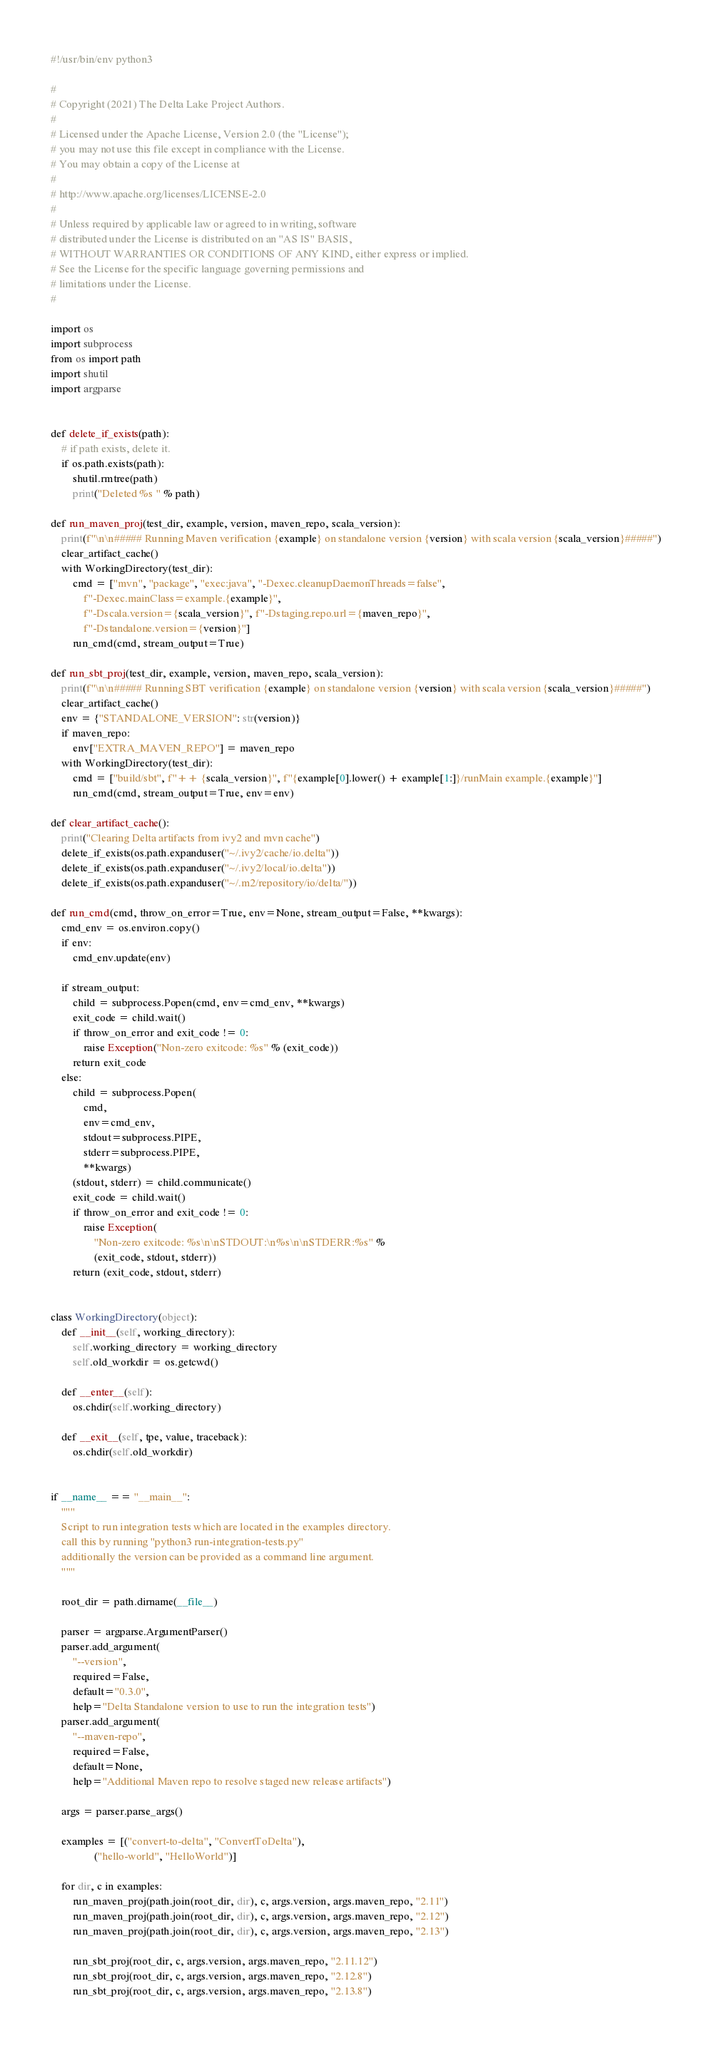<code> <loc_0><loc_0><loc_500><loc_500><_Python_>#!/usr/bin/env python3

#
# Copyright (2021) The Delta Lake Project Authors.
#
# Licensed under the Apache License, Version 2.0 (the "License");
# you may not use this file except in compliance with the License.
# You may obtain a copy of the License at
#
# http://www.apache.org/licenses/LICENSE-2.0
#
# Unless required by applicable law or agreed to in writing, software
# distributed under the License is distributed on an "AS IS" BASIS,
# WITHOUT WARRANTIES OR CONDITIONS OF ANY KIND, either express or implied.
# See the License for the specific language governing permissions and
# limitations under the License.
#

import os
import subprocess
from os import path
import shutil
import argparse


def delete_if_exists(path):
    # if path exists, delete it.
    if os.path.exists(path):
        shutil.rmtree(path)
        print("Deleted %s " % path)

def run_maven_proj(test_dir, example, version, maven_repo, scala_version):
    print(f"\n\n##### Running Maven verification {example} on standalone version {version} with scala version {scala_version}#####")
    clear_artifact_cache()
    with WorkingDirectory(test_dir):
        cmd = ["mvn", "package", "exec:java", "-Dexec.cleanupDaemonThreads=false",
            f"-Dexec.mainClass=example.{example}",
            f"-Dscala.version={scala_version}", f"-Dstaging.repo.url={maven_repo}",
            f"-Dstandalone.version={version}"]
        run_cmd(cmd, stream_output=True)

def run_sbt_proj(test_dir, example, version, maven_repo, scala_version):
    print(f"\n\n##### Running SBT verification {example} on standalone version {version} with scala version {scala_version}#####")
    clear_artifact_cache()
    env = {"STANDALONE_VERSION": str(version)}
    if maven_repo:
        env["EXTRA_MAVEN_REPO"] = maven_repo
    with WorkingDirectory(test_dir):
        cmd = ["build/sbt", f"++ {scala_version}", f"{example[0].lower() + example[1:]}/runMain example.{example}"]
        run_cmd(cmd, stream_output=True, env=env)

def clear_artifact_cache():
    print("Clearing Delta artifacts from ivy2 and mvn cache")
    delete_if_exists(os.path.expanduser("~/.ivy2/cache/io.delta"))
    delete_if_exists(os.path.expanduser("~/.ivy2/local/io.delta"))
    delete_if_exists(os.path.expanduser("~/.m2/repository/io/delta/"))

def run_cmd(cmd, throw_on_error=True, env=None, stream_output=False, **kwargs):
    cmd_env = os.environ.copy()
    if env:
        cmd_env.update(env)

    if stream_output:
        child = subprocess.Popen(cmd, env=cmd_env, **kwargs)
        exit_code = child.wait()
        if throw_on_error and exit_code != 0:
            raise Exception("Non-zero exitcode: %s" % (exit_code))
        return exit_code
    else:
        child = subprocess.Popen(
            cmd,
            env=cmd_env,
            stdout=subprocess.PIPE,
            stderr=subprocess.PIPE,
            **kwargs)
        (stdout, stderr) = child.communicate()
        exit_code = child.wait()
        if throw_on_error and exit_code != 0:
            raise Exception(
                "Non-zero exitcode: %s\n\nSTDOUT:\n%s\n\nSTDERR:%s" %
                (exit_code, stdout, stderr))
        return (exit_code, stdout, stderr)


class WorkingDirectory(object):
    def __init__(self, working_directory):
        self.working_directory = working_directory
        self.old_workdir = os.getcwd()

    def __enter__(self):
        os.chdir(self.working_directory)

    def __exit__(self, tpe, value, traceback):
        os.chdir(self.old_workdir)


if __name__ == "__main__":
    """
    Script to run integration tests which are located in the examples directory.
    call this by running "python3 run-integration-tests.py"
    additionally the version can be provided as a command line argument.
    """

    root_dir = path.dirname(__file__)

    parser = argparse.ArgumentParser()
    parser.add_argument(
        "--version",
        required=False,
        default="0.3.0",
        help="Delta Standalone version to use to run the integration tests")
    parser.add_argument(
        "--maven-repo",
        required=False,
        default=None,
        help="Additional Maven repo to resolve staged new release artifacts")

    args = parser.parse_args()

    examples = [("convert-to-delta", "ConvertToDelta"),
                ("hello-world", "HelloWorld")]

    for dir, c in examples:
        run_maven_proj(path.join(root_dir, dir), c, args.version, args.maven_repo, "2.11")
        run_maven_proj(path.join(root_dir, dir), c, args.version, args.maven_repo, "2.12")
        run_maven_proj(path.join(root_dir, dir), c, args.version, args.maven_repo, "2.13")

        run_sbt_proj(root_dir, c, args.version, args.maven_repo, "2.11.12")
        run_sbt_proj(root_dir, c, args.version, args.maven_repo, "2.12.8")
        run_sbt_proj(root_dir, c, args.version, args.maven_repo, "2.13.8")
</code> 